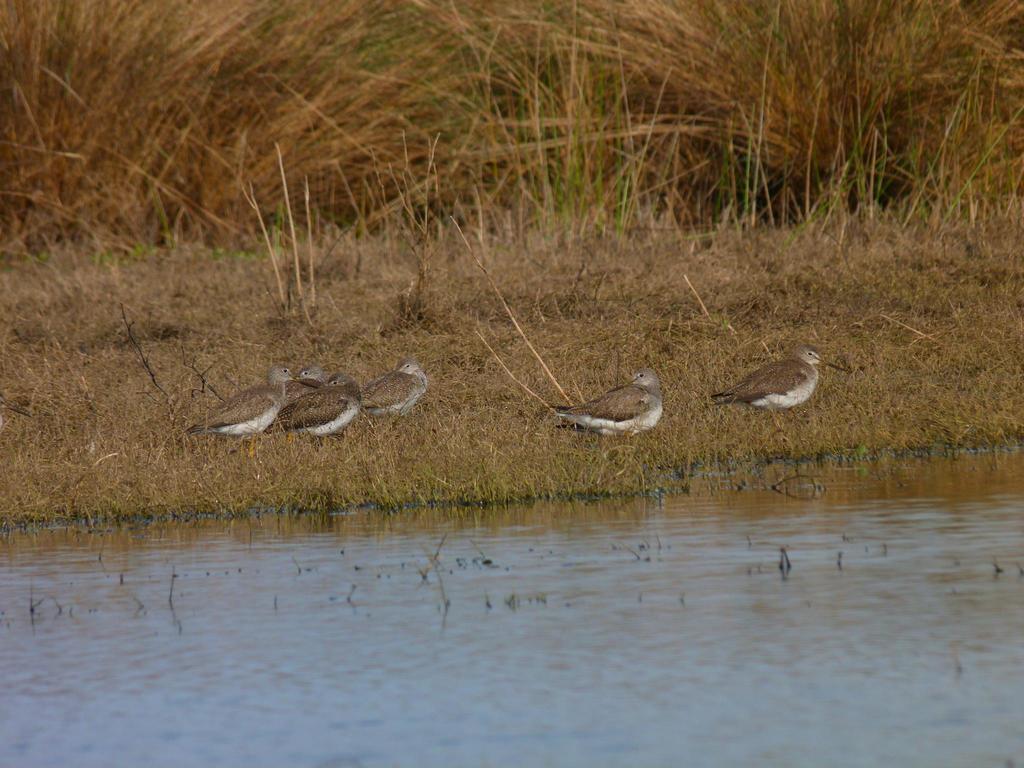How would you summarize this image in a sentence or two? In this picture we can see water. We can see a few birds on the grass. 